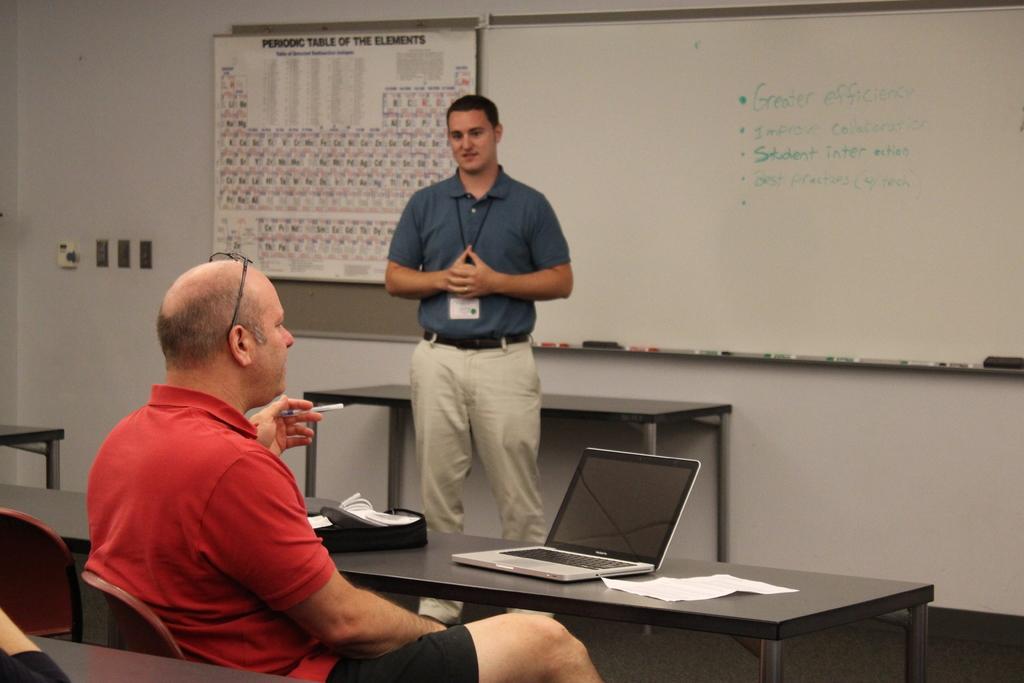Please provide a concise description of this image. This picture shows a man standing wearing a ID card on his neck and we see a another man seated on the chair and we see a laptop and a paper on the table and we see a white board and a poster on the left side 